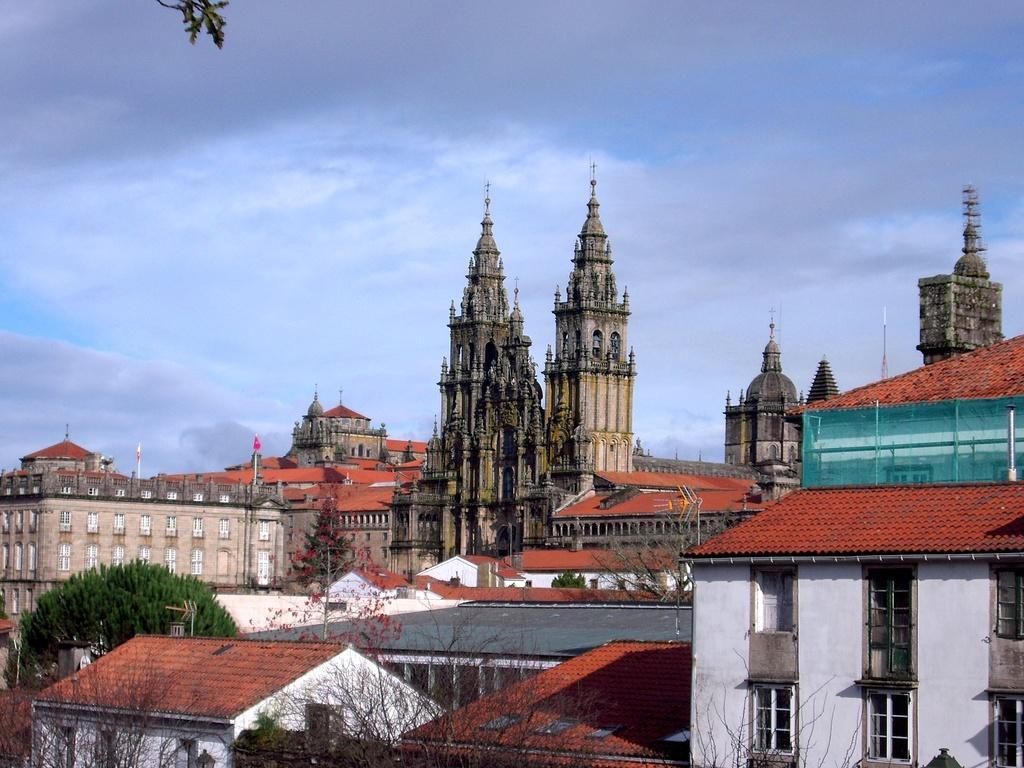How would you summarize this image in a sentence or two? In the image I can see the view of a place where we have some buildings, houses, trees, plants to which there are some flowers. 